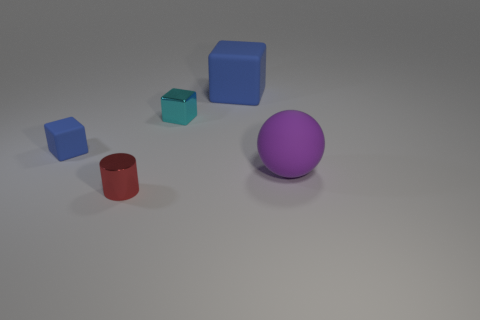Subtract all blue matte blocks. How many blocks are left? 1 Add 2 blue matte objects. How many objects exist? 7 Subtract all spheres. How many objects are left? 4 Subtract all small metal things. Subtract all tiny cyan shiny blocks. How many objects are left? 2 Add 5 big cubes. How many big cubes are left? 6 Add 3 tiny gray cylinders. How many tiny gray cylinders exist? 3 Subtract 1 red cylinders. How many objects are left? 4 